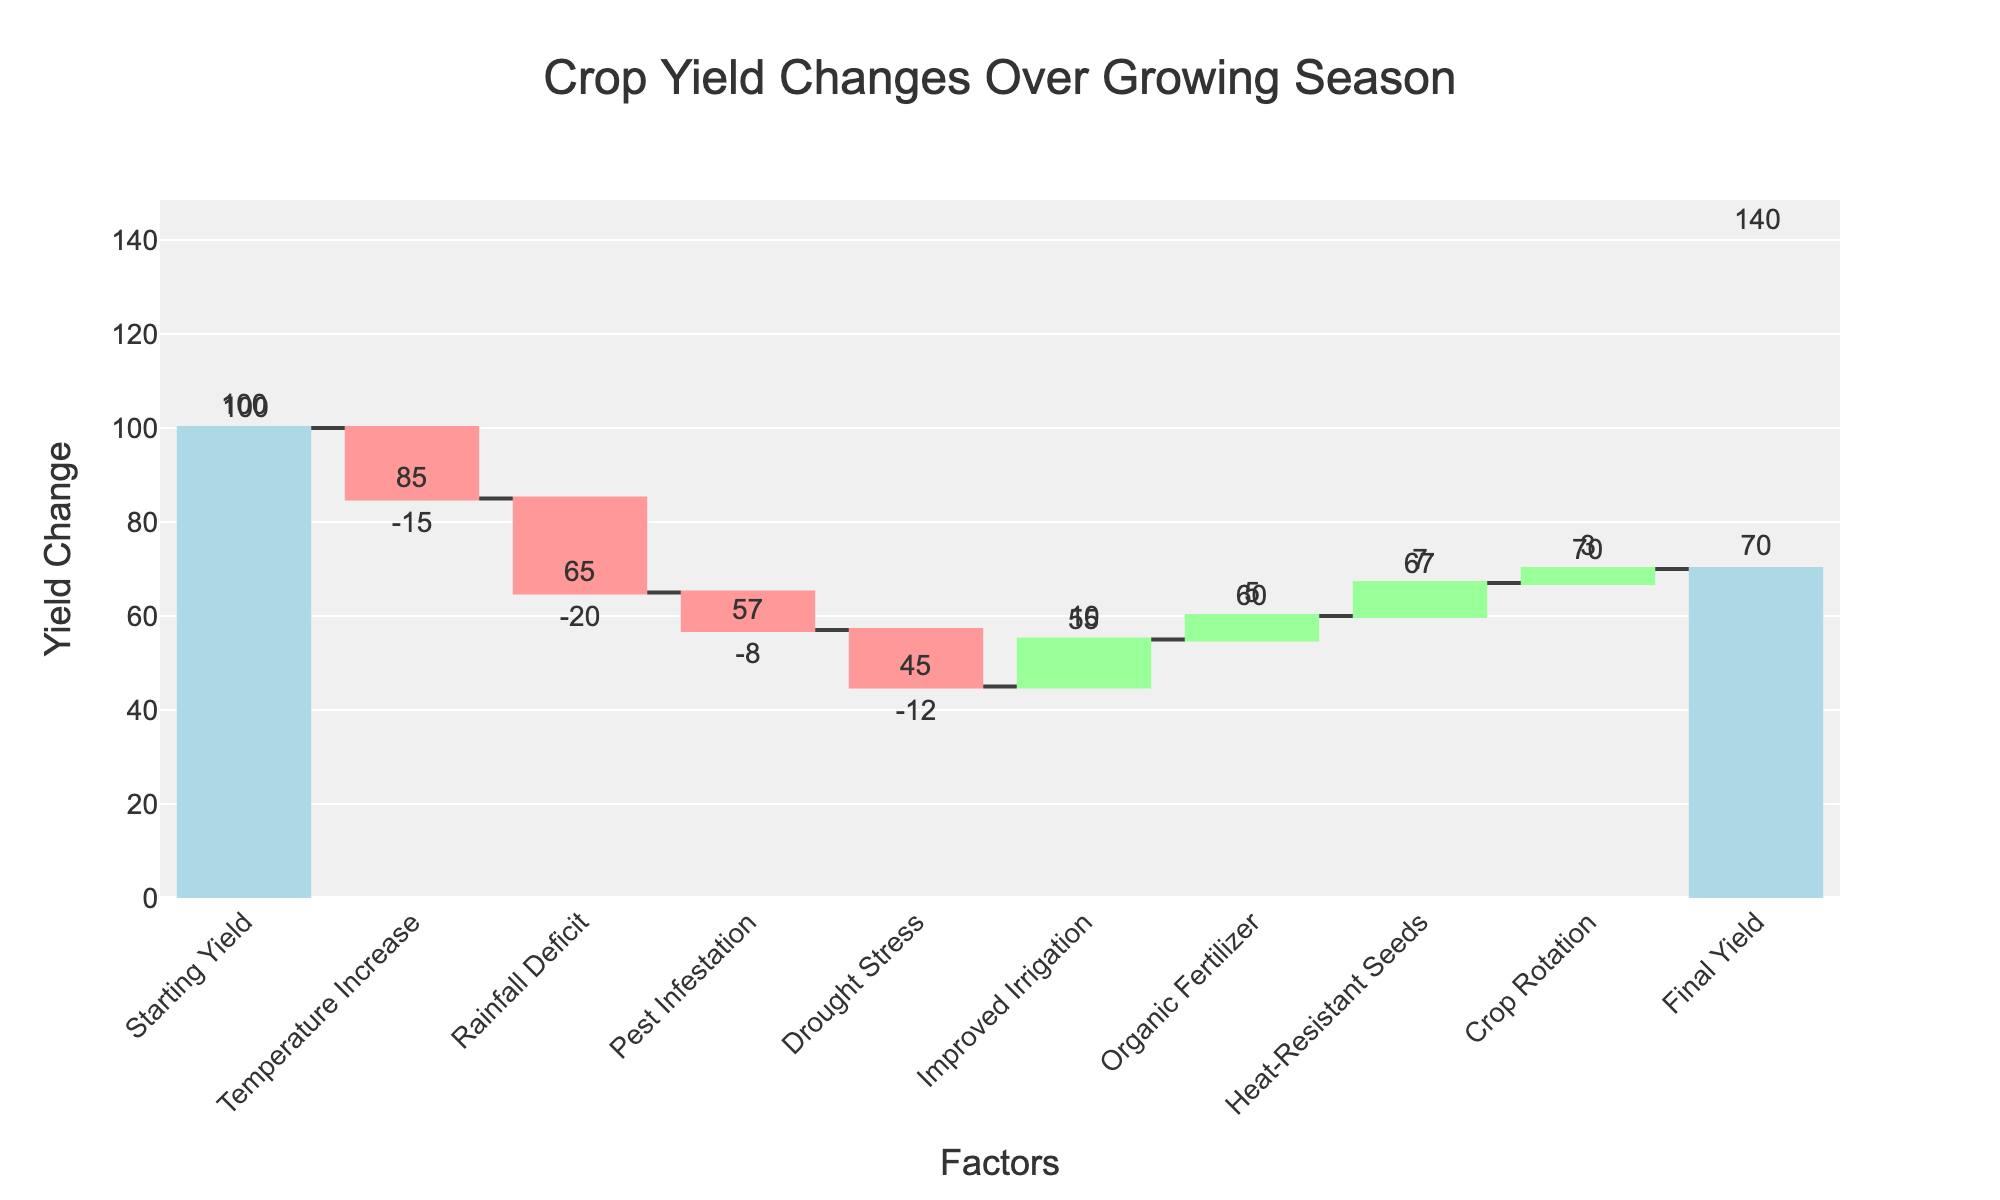What is the starting yield in the figure? The starting yield is explicitly labeled as "Starting Yield" in the figure, and the given change for this category is 100.
Answer: 100 What is the total yield loss due to Temperature Increase, Rainfall Deficit, Pest Infestation, and Drought Stress? To find the total yield loss, sum the changes for these factors: -15 (Temperature Increase) + -20 (Rainfall Deficit) + -8 (Pest Infestation) + -12 (Drought Stress). So, the calculation is -15 + -20 + -8 + -12 = -55.
Answer: -55 Which factor improved the yield the most? By examining the positive changes, Improved Irrigation has the highest increase of +10 compared to Organic Fertilizer (+5), Heat-Resistant Seeds (+7), and Crop Rotation (+3).
Answer: Improved Irrigation How much did the final yield change from the starting yield? The total change in yield is represented by the difference between the Starting Yield (100) and the Final Yield (70). The calculation is 100 - 70 = 30. Thus, the yield decreased by 30 units overall.
Answer: -30 What yields a better result: Improved Irrigation or Drought Stress mitigation? By comparing the positive impact of Improved Irrigation (+10) against the negative impact of Drought Stress (-12), Improved Irrigation has a better result because it positively affects the yield, while Drought Stress negatively affects it.
Answer: Improved Irrigation Which factor caused the highest single yield loss? By checking the negative changes, Rainfall Deficit has the largest negative impact with a change of -20, compared to other negative factors like Temperature Increase (-15), Pest Infestation (-8), and Drought Stress (-12).
Answer: Rainfall Deficit What is the cumulative yield after Pest Infestation? To find the cumulative yield after Pest Infestation, we sum up the yield changes sequentially until Pest Infestation: 100 (Starting Yield) + -15 (Temperature Increase) + -20 (Rainfall Deficit) + -8 (Pest Infestation) = 57.
Answer: 57 If only positive changes are considered, what would the final yield be? Calculate the starting yield and add all positive changes: 100 (Starting Yield) + 10 (Improved Irrigation) + 5 (Organic Fertilizer) + 7 (Heat-Resistant Seeds) + 3 (Crop Rotation) = 125.
Answer: 125 